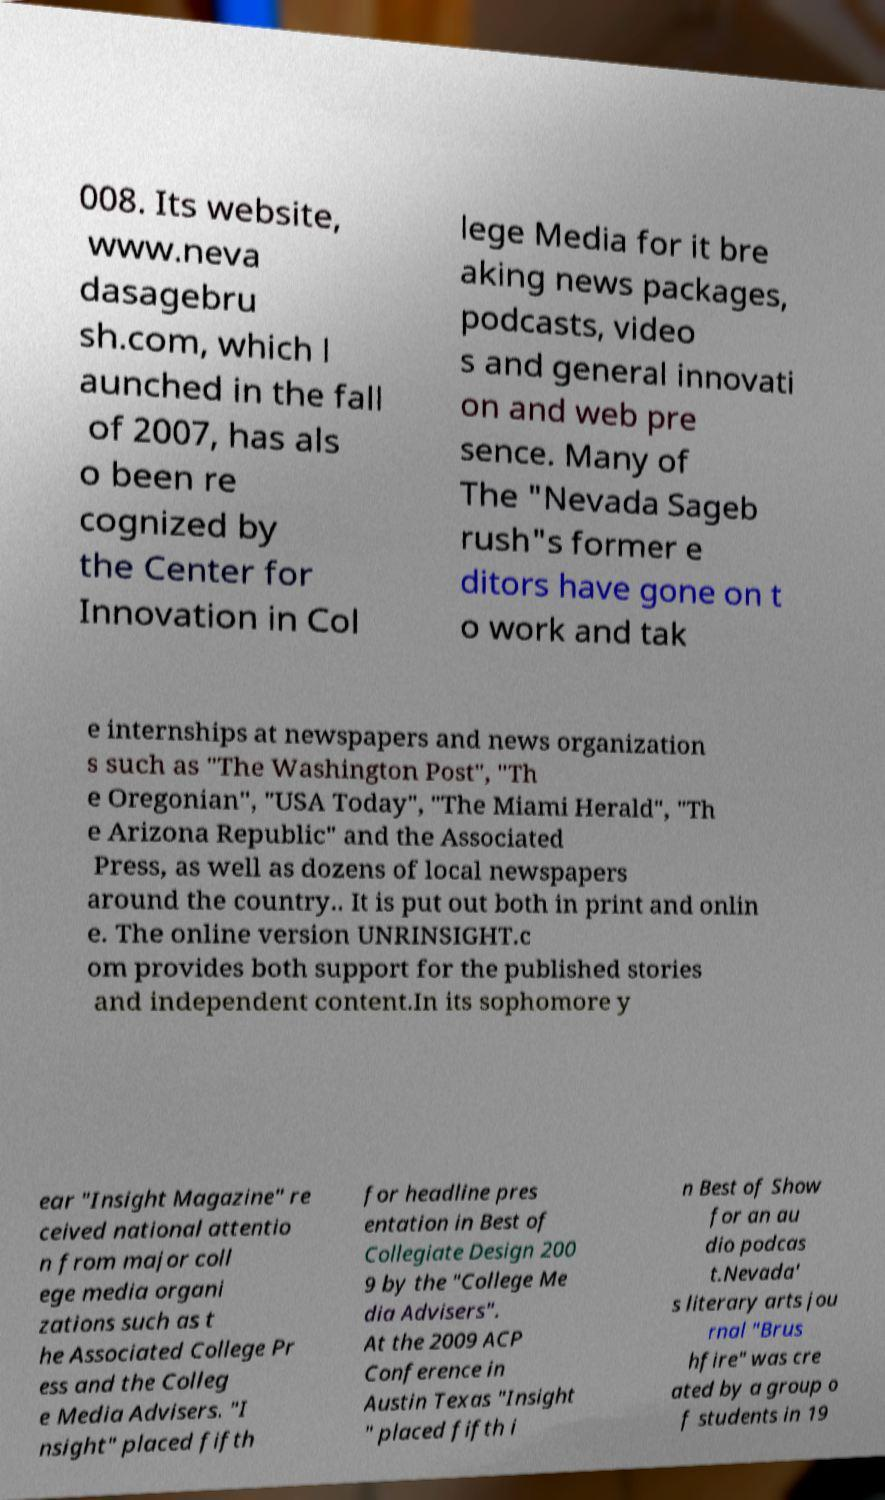Could you extract and type out the text from this image? 008. Its website, www.neva dasagebru sh.com, which l aunched in the fall of 2007, has als o been re cognized by the Center for Innovation in Col lege Media for it bre aking news packages, podcasts, video s and general innovati on and web pre sence. Many of The "Nevada Sageb rush"s former e ditors have gone on t o work and tak e internships at newspapers and news organization s such as "The Washington Post", "Th e Oregonian", "USA Today", "The Miami Herald", "Th e Arizona Republic" and the Associated Press, as well as dozens of local newspapers around the country.. It is put out both in print and onlin e. The online version UNRINSIGHT.c om provides both support for the published stories and independent content.In its sophomore y ear "Insight Magazine" re ceived national attentio n from major coll ege media organi zations such as t he Associated College Pr ess and the Colleg e Media Advisers. "I nsight" placed fifth for headline pres entation in Best of Collegiate Design 200 9 by the "College Me dia Advisers". At the 2009 ACP Conference in Austin Texas "Insight " placed fifth i n Best of Show for an au dio podcas t.Nevada' s literary arts jou rnal "Brus hfire" was cre ated by a group o f students in 19 